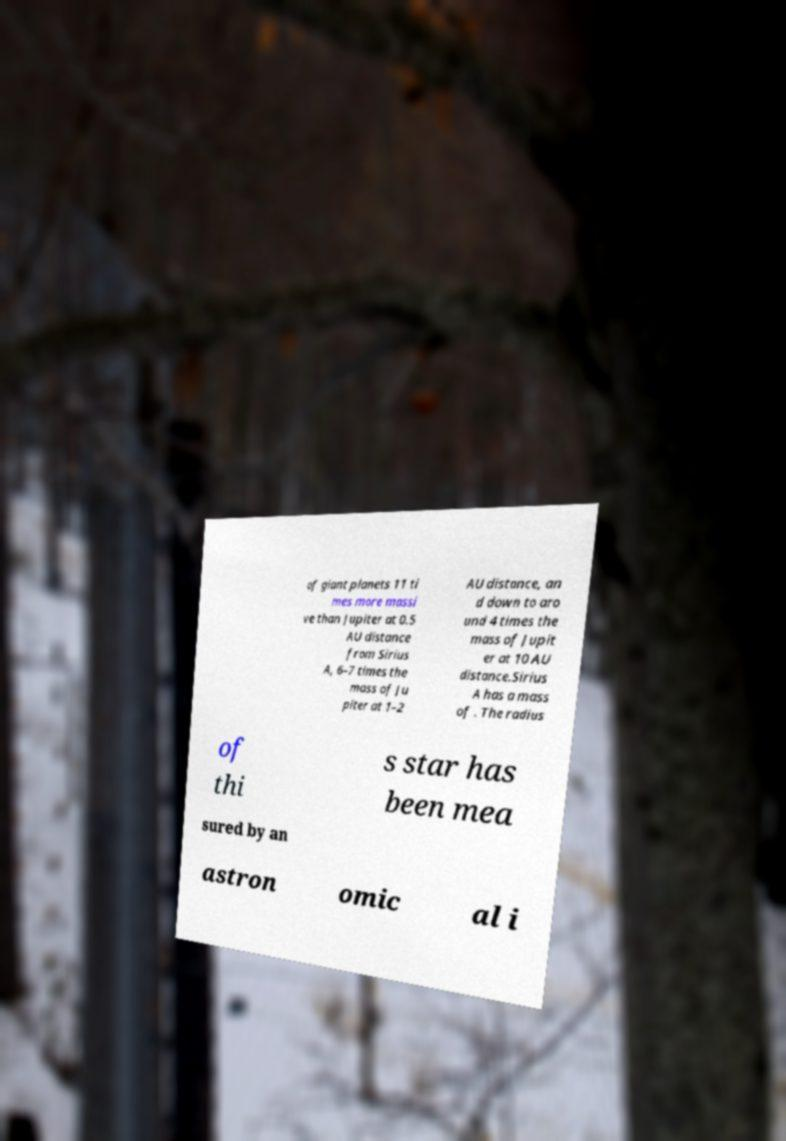Could you extract and type out the text from this image? of giant planets 11 ti mes more massi ve than Jupiter at 0.5 AU distance from Sirius A, 6–7 times the mass of Ju piter at 1–2 AU distance, an d down to aro und 4 times the mass of Jupit er at 10 AU distance.Sirius A has a mass of . The radius of thi s star has been mea sured by an astron omic al i 